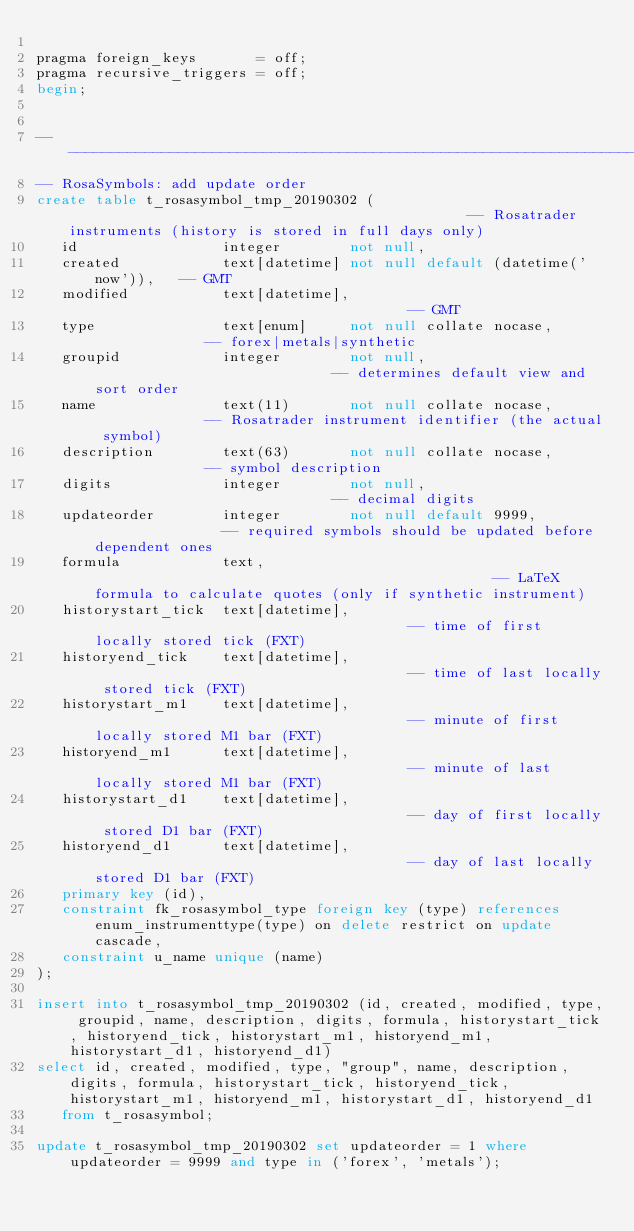<code> <loc_0><loc_0><loc_500><loc_500><_SQL_>
pragma foreign_keys       = off;
pragma recursive_triggers = off;
begin;


-- --------------------------------------------------------------------------------------------------------------------------------------------------------------------------
-- RosaSymbols: add update order
create table t_rosasymbol_tmp_20190302 (                                                -- Rosatrader instruments (history is stored in full days only)
   id                 integer        not null,
   created            text[datetime] not null default (datetime('now')),   -- GMT
   modified           text[datetime],                                      -- GMT
   type               text[enum]     not null collate nocase,              -- forex|metals|synthetic
   groupid            integer        not null,                             -- determines default view and sort order
   name               text(11)       not null collate nocase,              -- Rosatrader instrument identifier (the actual symbol)
   description        text(63)       not null collate nocase,              -- symbol description
   digits             integer        not null,                             -- decimal digits
   updateorder        integer        not null default 9999,                -- required symbols should be updated before dependent ones
   formula            text,                                                -- LaTeX formula to calculate quotes (only if synthetic instrument)
   historystart_tick  text[datetime],                                      -- time of first locally stored tick (FXT)
   historyend_tick    text[datetime],                                      -- time of last locally stored tick (FXT)
   historystart_m1    text[datetime],                                      -- minute of first locally stored M1 bar (FXT)
   historyend_m1      text[datetime],                                      -- minute of last locally stored M1 bar (FXT)
   historystart_d1    text[datetime],                                      -- day of first locally stored D1 bar (FXT)
   historyend_d1      text[datetime],                                      -- day of last locally stored D1 bar (FXT)
   primary key (id),
   constraint fk_rosasymbol_type foreign key (type) references enum_instrumenttype(type) on delete restrict on update cascade,
   constraint u_name unique (name)
);

insert into t_rosasymbol_tmp_20190302 (id, created, modified, type, groupid, name, description, digits, formula, historystart_tick, historyend_tick, historystart_m1, historyend_m1, historystart_d1, historyend_d1)
select id, created, modified, type, "group", name, description, digits, formula, historystart_tick, historyend_tick, historystart_m1, historyend_m1, historystart_d1, historyend_d1
   from t_rosasymbol;

update t_rosasymbol_tmp_20190302 set updateorder = 1 where updateorder = 9999 and type in ('forex', 'metals');</code> 